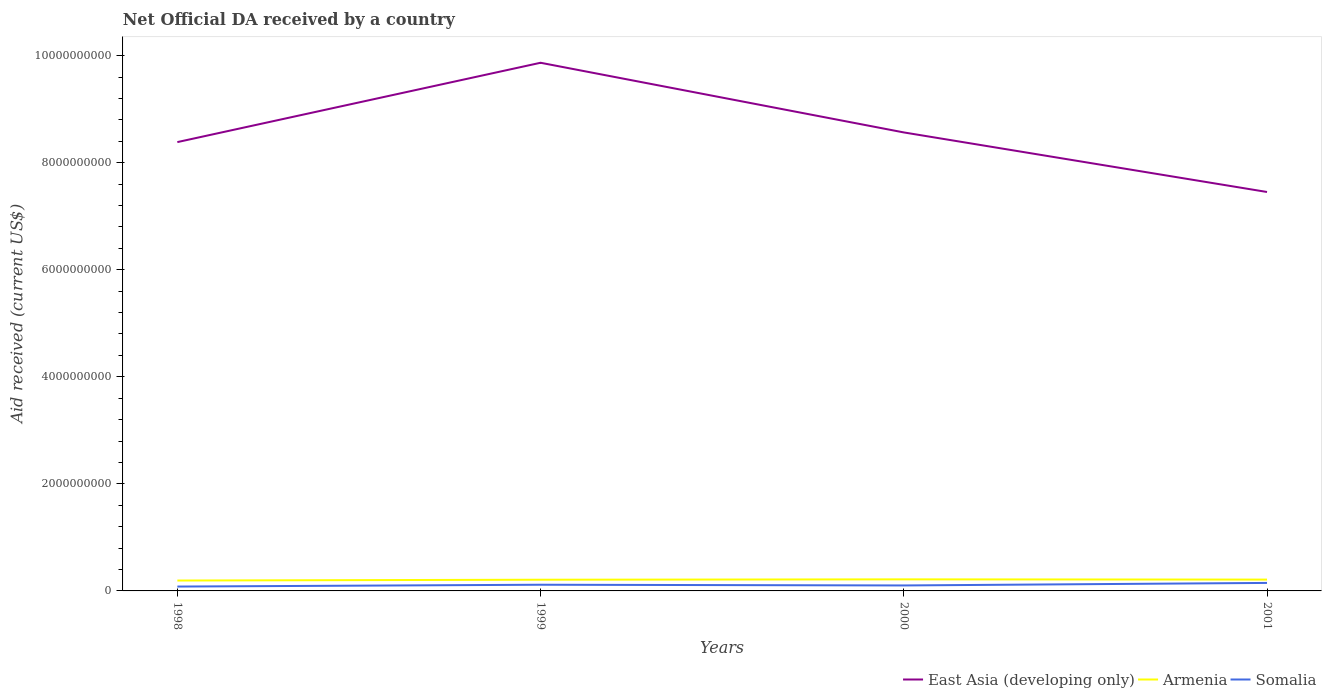Is the number of lines equal to the number of legend labels?
Your answer should be very brief. Yes. Across all years, what is the maximum net official development assistance aid received in Somalia?
Make the answer very short. 8.13e+07. In which year was the net official development assistance aid received in Armenia maximum?
Offer a very short reply. 1998. What is the total net official development assistance aid received in East Asia (developing only) in the graph?
Keep it short and to the point. 9.32e+08. What is the difference between the highest and the second highest net official development assistance aid received in Somalia?
Provide a short and direct response. 6.80e+07. What is the difference between the highest and the lowest net official development assistance aid received in East Asia (developing only)?
Provide a short and direct response. 1. Is the net official development assistance aid received in Somalia strictly greater than the net official development assistance aid received in Armenia over the years?
Your answer should be compact. Yes. How many lines are there?
Keep it short and to the point. 3. How many years are there in the graph?
Ensure brevity in your answer.  4. Are the values on the major ticks of Y-axis written in scientific E-notation?
Your answer should be very brief. No. Does the graph contain any zero values?
Give a very brief answer. No. Where does the legend appear in the graph?
Your answer should be compact. Bottom right. How many legend labels are there?
Make the answer very short. 3. What is the title of the graph?
Provide a succinct answer. Net Official DA received by a country. Does "Croatia" appear as one of the legend labels in the graph?
Keep it short and to the point. No. What is the label or title of the Y-axis?
Make the answer very short. Aid received (current US$). What is the Aid received (current US$) in East Asia (developing only) in 1998?
Provide a succinct answer. 8.38e+09. What is the Aid received (current US$) of Armenia in 1998?
Provide a succinct answer. 1.94e+08. What is the Aid received (current US$) in Somalia in 1998?
Ensure brevity in your answer.  8.13e+07. What is the Aid received (current US$) in East Asia (developing only) in 1999?
Provide a short and direct response. 9.87e+09. What is the Aid received (current US$) of Armenia in 1999?
Your response must be concise. 2.09e+08. What is the Aid received (current US$) of Somalia in 1999?
Keep it short and to the point. 1.16e+08. What is the Aid received (current US$) in East Asia (developing only) in 2000?
Offer a very short reply. 8.57e+09. What is the Aid received (current US$) in Armenia in 2000?
Make the answer very short. 2.16e+08. What is the Aid received (current US$) of Somalia in 2000?
Provide a short and direct response. 1.02e+08. What is the Aid received (current US$) in East Asia (developing only) in 2001?
Offer a very short reply. 7.45e+09. What is the Aid received (current US$) in Armenia in 2001?
Make the answer very short. 2.12e+08. What is the Aid received (current US$) of Somalia in 2001?
Offer a very short reply. 1.49e+08. Across all years, what is the maximum Aid received (current US$) in East Asia (developing only)?
Your answer should be compact. 9.87e+09. Across all years, what is the maximum Aid received (current US$) in Armenia?
Make the answer very short. 2.16e+08. Across all years, what is the maximum Aid received (current US$) of Somalia?
Make the answer very short. 1.49e+08. Across all years, what is the minimum Aid received (current US$) of East Asia (developing only)?
Give a very brief answer. 7.45e+09. Across all years, what is the minimum Aid received (current US$) in Armenia?
Give a very brief answer. 1.94e+08. Across all years, what is the minimum Aid received (current US$) of Somalia?
Your answer should be very brief. 8.13e+07. What is the total Aid received (current US$) of East Asia (developing only) in the graph?
Your answer should be very brief. 3.43e+1. What is the total Aid received (current US$) of Armenia in the graph?
Offer a very short reply. 8.31e+08. What is the total Aid received (current US$) in Somalia in the graph?
Provide a short and direct response. 4.49e+08. What is the difference between the Aid received (current US$) in East Asia (developing only) in 1998 and that in 1999?
Provide a short and direct response. -1.48e+09. What is the difference between the Aid received (current US$) in Armenia in 1998 and that in 1999?
Offer a terse response. -1.50e+07. What is the difference between the Aid received (current US$) of Somalia in 1998 and that in 1999?
Your answer should be very brief. -3.44e+07. What is the difference between the Aid received (current US$) in East Asia (developing only) in 1998 and that in 2000?
Give a very brief answer. -1.81e+08. What is the difference between the Aid received (current US$) of Armenia in 1998 and that in 2000?
Provide a succinct answer. -2.17e+07. What is the difference between the Aid received (current US$) in Somalia in 1998 and that in 2000?
Keep it short and to the point. -2.09e+07. What is the difference between the Aid received (current US$) in East Asia (developing only) in 1998 and that in 2001?
Your answer should be very brief. 9.32e+08. What is the difference between the Aid received (current US$) in Armenia in 1998 and that in 2001?
Offer a terse response. -1.74e+07. What is the difference between the Aid received (current US$) of Somalia in 1998 and that in 2001?
Give a very brief answer. -6.80e+07. What is the difference between the Aid received (current US$) of East Asia (developing only) in 1999 and that in 2000?
Your answer should be compact. 1.30e+09. What is the difference between the Aid received (current US$) of Armenia in 1999 and that in 2000?
Your answer should be compact. -6.71e+06. What is the difference between the Aid received (current US$) in Somalia in 1999 and that in 2000?
Your answer should be very brief. 1.35e+07. What is the difference between the Aid received (current US$) of East Asia (developing only) in 1999 and that in 2001?
Offer a terse response. 2.41e+09. What is the difference between the Aid received (current US$) of Armenia in 1999 and that in 2001?
Give a very brief answer. -2.45e+06. What is the difference between the Aid received (current US$) in Somalia in 1999 and that in 2001?
Your answer should be very brief. -3.36e+07. What is the difference between the Aid received (current US$) in East Asia (developing only) in 2000 and that in 2001?
Ensure brevity in your answer.  1.11e+09. What is the difference between the Aid received (current US$) in Armenia in 2000 and that in 2001?
Offer a terse response. 4.26e+06. What is the difference between the Aid received (current US$) of Somalia in 2000 and that in 2001?
Provide a succinct answer. -4.71e+07. What is the difference between the Aid received (current US$) of East Asia (developing only) in 1998 and the Aid received (current US$) of Armenia in 1999?
Your response must be concise. 8.18e+09. What is the difference between the Aid received (current US$) of East Asia (developing only) in 1998 and the Aid received (current US$) of Somalia in 1999?
Your response must be concise. 8.27e+09. What is the difference between the Aid received (current US$) in Armenia in 1998 and the Aid received (current US$) in Somalia in 1999?
Give a very brief answer. 7.85e+07. What is the difference between the Aid received (current US$) of East Asia (developing only) in 1998 and the Aid received (current US$) of Armenia in 2000?
Provide a succinct answer. 8.17e+09. What is the difference between the Aid received (current US$) of East Asia (developing only) in 1998 and the Aid received (current US$) of Somalia in 2000?
Give a very brief answer. 8.28e+09. What is the difference between the Aid received (current US$) in Armenia in 1998 and the Aid received (current US$) in Somalia in 2000?
Offer a terse response. 9.20e+07. What is the difference between the Aid received (current US$) in East Asia (developing only) in 1998 and the Aid received (current US$) in Armenia in 2001?
Keep it short and to the point. 8.17e+09. What is the difference between the Aid received (current US$) of East Asia (developing only) in 1998 and the Aid received (current US$) of Somalia in 2001?
Ensure brevity in your answer.  8.24e+09. What is the difference between the Aid received (current US$) in Armenia in 1998 and the Aid received (current US$) in Somalia in 2001?
Offer a terse response. 4.49e+07. What is the difference between the Aid received (current US$) of East Asia (developing only) in 1999 and the Aid received (current US$) of Armenia in 2000?
Your answer should be very brief. 9.65e+09. What is the difference between the Aid received (current US$) in East Asia (developing only) in 1999 and the Aid received (current US$) in Somalia in 2000?
Provide a short and direct response. 9.76e+09. What is the difference between the Aid received (current US$) of Armenia in 1999 and the Aid received (current US$) of Somalia in 2000?
Make the answer very short. 1.07e+08. What is the difference between the Aid received (current US$) of East Asia (developing only) in 1999 and the Aid received (current US$) of Armenia in 2001?
Ensure brevity in your answer.  9.65e+09. What is the difference between the Aid received (current US$) in East Asia (developing only) in 1999 and the Aid received (current US$) in Somalia in 2001?
Keep it short and to the point. 9.72e+09. What is the difference between the Aid received (current US$) of Armenia in 1999 and the Aid received (current US$) of Somalia in 2001?
Give a very brief answer. 5.99e+07. What is the difference between the Aid received (current US$) of East Asia (developing only) in 2000 and the Aid received (current US$) of Armenia in 2001?
Provide a succinct answer. 8.35e+09. What is the difference between the Aid received (current US$) of East Asia (developing only) in 2000 and the Aid received (current US$) of Somalia in 2001?
Provide a succinct answer. 8.42e+09. What is the difference between the Aid received (current US$) of Armenia in 2000 and the Aid received (current US$) of Somalia in 2001?
Provide a succinct answer. 6.66e+07. What is the average Aid received (current US$) of East Asia (developing only) per year?
Your answer should be compact. 8.57e+09. What is the average Aid received (current US$) in Armenia per year?
Ensure brevity in your answer.  2.08e+08. What is the average Aid received (current US$) in Somalia per year?
Keep it short and to the point. 1.12e+08. In the year 1998, what is the difference between the Aid received (current US$) of East Asia (developing only) and Aid received (current US$) of Armenia?
Offer a terse response. 8.19e+09. In the year 1998, what is the difference between the Aid received (current US$) of East Asia (developing only) and Aid received (current US$) of Somalia?
Your answer should be compact. 8.30e+09. In the year 1998, what is the difference between the Aid received (current US$) in Armenia and Aid received (current US$) in Somalia?
Keep it short and to the point. 1.13e+08. In the year 1999, what is the difference between the Aid received (current US$) of East Asia (developing only) and Aid received (current US$) of Armenia?
Your answer should be compact. 9.66e+09. In the year 1999, what is the difference between the Aid received (current US$) in East Asia (developing only) and Aid received (current US$) in Somalia?
Your response must be concise. 9.75e+09. In the year 1999, what is the difference between the Aid received (current US$) of Armenia and Aid received (current US$) of Somalia?
Ensure brevity in your answer.  9.35e+07. In the year 2000, what is the difference between the Aid received (current US$) of East Asia (developing only) and Aid received (current US$) of Armenia?
Offer a very short reply. 8.35e+09. In the year 2000, what is the difference between the Aid received (current US$) of East Asia (developing only) and Aid received (current US$) of Somalia?
Ensure brevity in your answer.  8.46e+09. In the year 2000, what is the difference between the Aid received (current US$) of Armenia and Aid received (current US$) of Somalia?
Your answer should be compact. 1.14e+08. In the year 2001, what is the difference between the Aid received (current US$) in East Asia (developing only) and Aid received (current US$) in Armenia?
Your response must be concise. 7.24e+09. In the year 2001, what is the difference between the Aid received (current US$) in East Asia (developing only) and Aid received (current US$) in Somalia?
Offer a very short reply. 7.30e+09. In the year 2001, what is the difference between the Aid received (current US$) of Armenia and Aid received (current US$) of Somalia?
Your response must be concise. 6.23e+07. What is the ratio of the Aid received (current US$) of East Asia (developing only) in 1998 to that in 1999?
Offer a terse response. 0.85. What is the ratio of the Aid received (current US$) in Armenia in 1998 to that in 1999?
Offer a very short reply. 0.93. What is the ratio of the Aid received (current US$) of Somalia in 1998 to that in 1999?
Offer a terse response. 0.7. What is the ratio of the Aid received (current US$) in East Asia (developing only) in 1998 to that in 2000?
Provide a short and direct response. 0.98. What is the ratio of the Aid received (current US$) in Armenia in 1998 to that in 2000?
Your answer should be very brief. 0.9. What is the ratio of the Aid received (current US$) in Somalia in 1998 to that in 2000?
Provide a succinct answer. 0.8. What is the ratio of the Aid received (current US$) of East Asia (developing only) in 1998 to that in 2001?
Ensure brevity in your answer.  1.12. What is the ratio of the Aid received (current US$) of Armenia in 1998 to that in 2001?
Offer a very short reply. 0.92. What is the ratio of the Aid received (current US$) in Somalia in 1998 to that in 2001?
Ensure brevity in your answer.  0.54. What is the ratio of the Aid received (current US$) in East Asia (developing only) in 1999 to that in 2000?
Your answer should be compact. 1.15. What is the ratio of the Aid received (current US$) of Armenia in 1999 to that in 2000?
Provide a succinct answer. 0.97. What is the ratio of the Aid received (current US$) in Somalia in 1999 to that in 2000?
Give a very brief answer. 1.13. What is the ratio of the Aid received (current US$) of East Asia (developing only) in 1999 to that in 2001?
Your response must be concise. 1.32. What is the ratio of the Aid received (current US$) in Armenia in 1999 to that in 2001?
Provide a succinct answer. 0.99. What is the ratio of the Aid received (current US$) in Somalia in 1999 to that in 2001?
Keep it short and to the point. 0.77. What is the ratio of the Aid received (current US$) of East Asia (developing only) in 2000 to that in 2001?
Keep it short and to the point. 1.15. What is the ratio of the Aid received (current US$) of Armenia in 2000 to that in 2001?
Keep it short and to the point. 1.02. What is the ratio of the Aid received (current US$) in Somalia in 2000 to that in 2001?
Your answer should be very brief. 0.68. What is the difference between the highest and the second highest Aid received (current US$) of East Asia (developing only)?
Make the answer very short. 1.30e+09. What is the difference between the highest and the second highest Aid received (current US$) of Armenia?
Offer a very short reply. 4.26e+06. What is the difference between the highest and the second highest Aid received (current US$) in Somalia?
Offer a terse response. 3.36e+07. What is the difference between the highest and the lowest Aid received (current US$) in East Asia (developing only)?
Provide a succinct answer. 2.41e+09. What is the difference between the highest and the lowest Aid received (current US$) of Armenia?
Your response must be concise. 2.17e+07. What is the difference between the highest and the lowest Aid received (current US$) of Somalia?
Offer a terse response. 6.80e+07. 